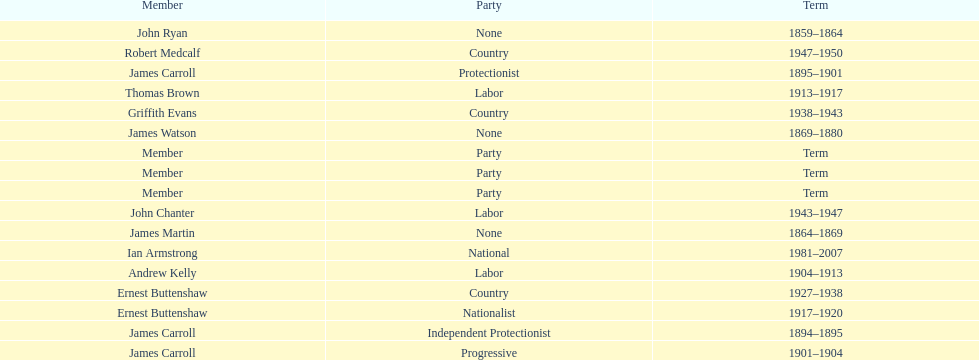Of the members of the third incarnation of the lachlan, who served the longest? Ernest Buttenshaw. 